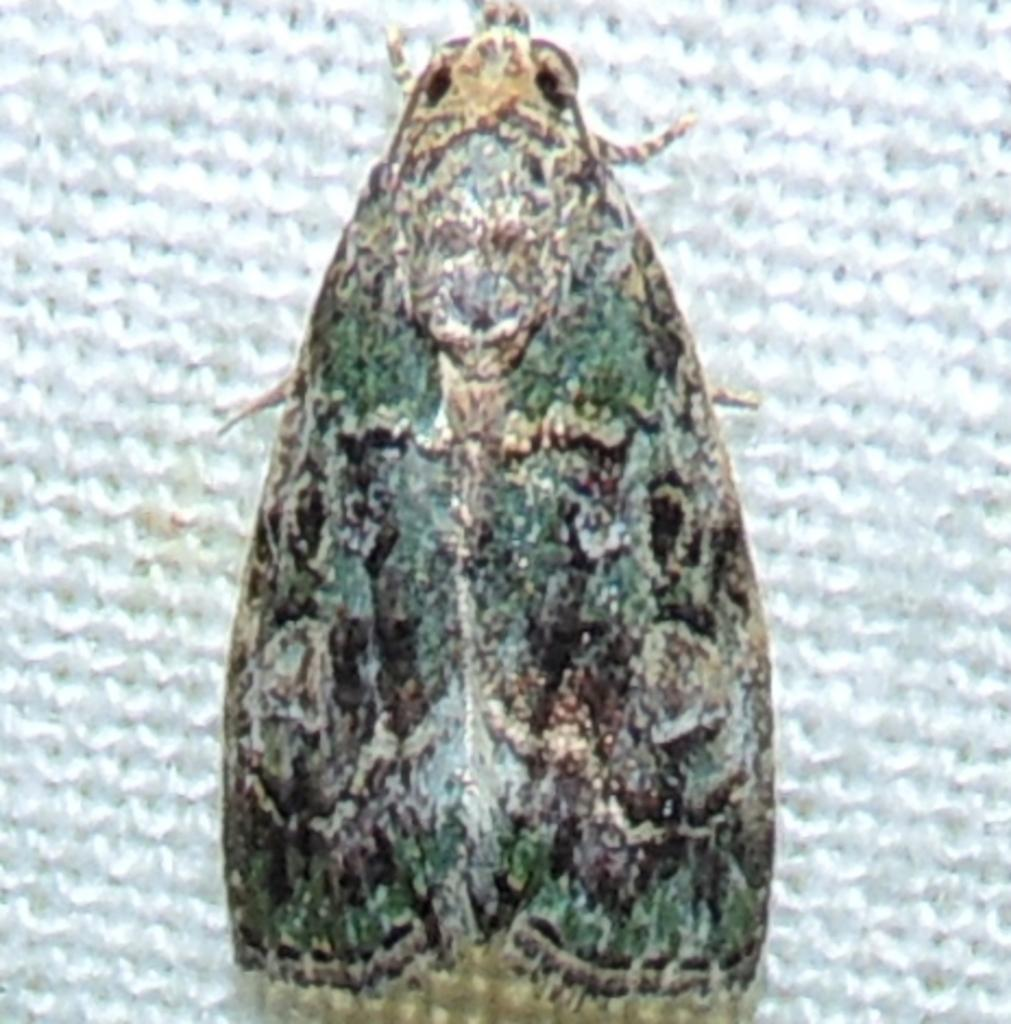What type of insect is present in the image? There is a moth in the image. What is the moth doing or resting on in the image? The moth is on an object in the image. What type of desk is visible in the image? There is no desk present in the image; it only features a moth on an object. 